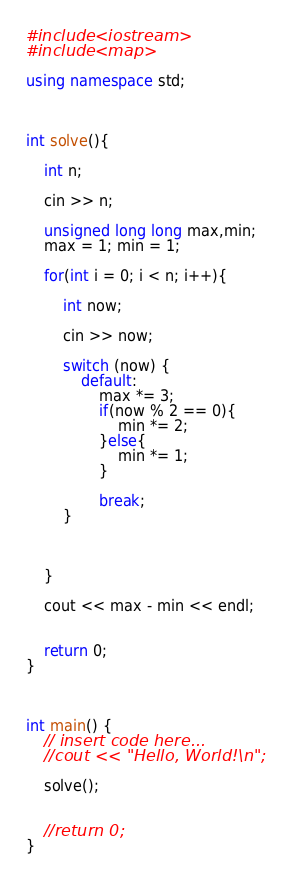<code> <loc_0><loc_0><loc_500><loc_500><_C++_>
#include <iostream>
#include <map>

using namespace std;



int solve(){

    int n;
    
    cin >> n;
    
    unsigned long long max,min;
    max = 1; min = 1;
    
    for(int i = 0; i < n; i++){
        
        int now;
        
        cin >> now;
        
        switch (now) {
            default:
                max *= 3;
                if(now % 2 == 0){
                    min *= 2;
                }else{
                    min *= 1;
                }
                
                break;
        }
        
        
        
    }
    
    cout << max - min << endl;
    
    
    return 0;
}



int main() {
    // insert code here...
    //cout << "Hello, World!\n";
    
    solve();
    
    
    //return 0;
}
</code> 